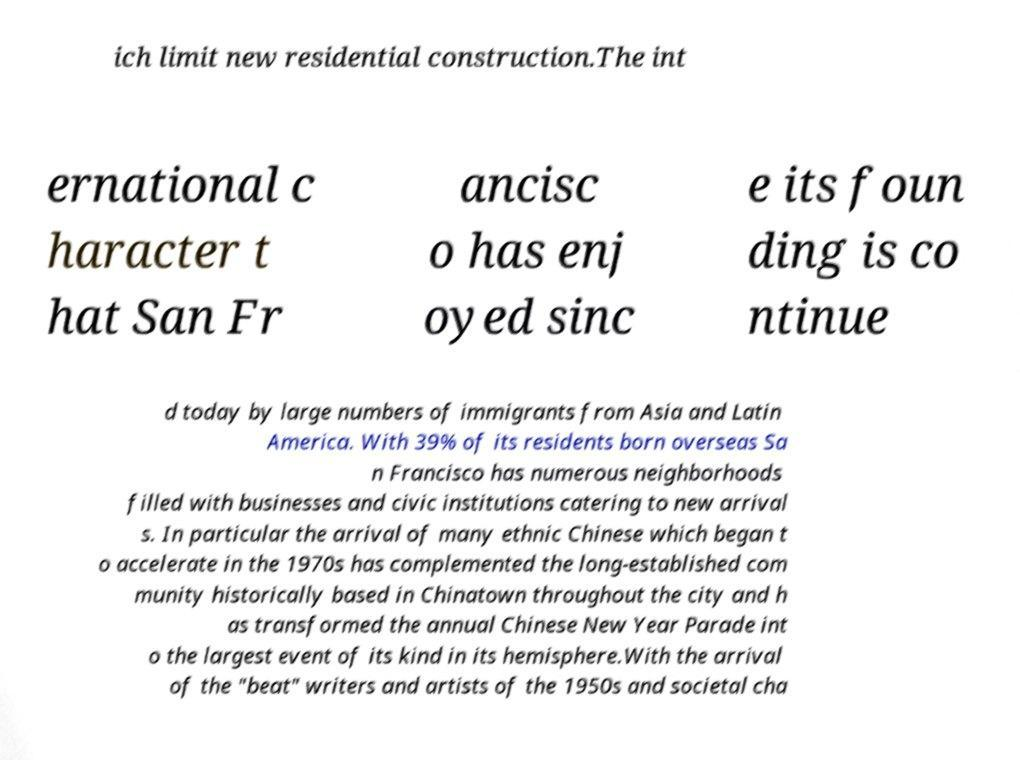There's text embedded in this image that I need extracted. Can you transcribe it verbatim? ich limit new residential construction.The int ernational c haracter t hat San Fr ancisc o has enj oyed sinc e its foun ding is co ntinue d today by large numbers of immigrants from Asia and Latin America. With 39% of its residents born overseas Sa n Francisco has numerous neighborhoods filled with businesses and civic institutions catering to new arrival s. In particular the arrival of many ethnic Chinese which began t o accelerate in the 1970s has complemented the long-established com munity historically based in Chinatown throughout the city and h as transformed the annual Chinese New Year Parade int o the largest event of its kind in its hemisphere.With the arrival of the "beat" writers and artists of the 1950s and societal cha 